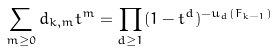<formula> <loc_0><loc_0><loc_500><loc_500>\sum _ { m \geq 0 } d _ { k , m } t ^ { m } = \prod _ { d \geq 1 } ( 1 - t ^ { d } ) ^ { - u _ { d } ( F _ { k - 1 } ) }</formula> 